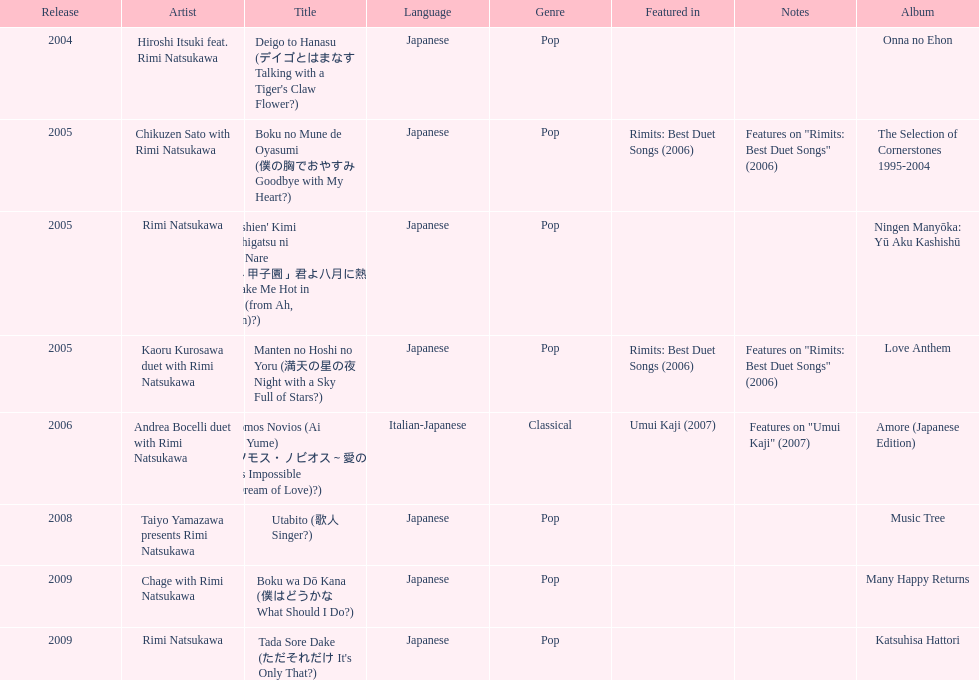I'm looking to parse the entire table for insights. Could you assist me with that? {'header': ['Release', 'Artist', 'Title', 'Language', 'Genre', 'Featured in', 'Notes', 'Album'], 'rows': [['2004', 'Hiroshi Itsuki feat. Rimi Natsukawa', "Deigo to Hanasu (デイゴとはまなす Talking with a Tiger's Claw Flower?)", 'Japanese', 'Pop', '', '', 'Onna no Ehon'], ['2005', 'Chikuzen Sato with Rimi Natsukawa', 'Boku no Mune de Oyasumi (僕の胸でおやすみ Goodbye with My Heart?)', 'Japanese', 'Pop', 'Rimits: Best Duet Songs (2006)', 'Features on "Rimits: Best Duet Songs" (2006)', 'The Selection of Cornerstones 1995-2004'], ['2005', 'Rimi Natsukawa', "'Aa Kōshien' Kimi yo Hachigatsu ni Atsuku Nare (「あゝ甲子園」君よ八月に熱くなれ You Make Me Hot in August (from Ah, Kōshien)?)", 'Japanese', 'Pop', '', '', 'Ningen Manyōka: Yū Aku Kashishū'], ['2005', 'Kaoru Kurosawa duet with Rimi Natsukawa', 'Manten no Hoshi no Yoru (満天の星の夜 Night with a Sky Full of Stars?)', 'Japanese', 'Pop', 'Rimits: Best Duet Songs (2006)', 'Features on "Rimits: Best Duet Songs" (2006)', 'Love Anthem'], ['2006', 'Andrea Bocelli duet with Rimi Natsukawa', "Somos Novios (Ai no Yume) (ソモス・ノビオス～愛の夢 It's Impossible (Dream of Love)?)", 'Italian-Japanese', 'Classical', 'Umui Kaji (2007)', 'Features on "Umui Kaji" (2007)', 'Amore (Japanese Edition)'], ['2008', 'Taiyo Yamazawa presents Rimi Natsukawa', 'Utabito (歌人 Singer?)', 'Japanese', 'Pop', '', '', 'Music Tree'], ['2009', 'Chage with Rimi Natsukawa', 'Boku wa Dō Kana (僕はどうかな What Should I Do?)', 'Japanese', 'Pop', '', '', 'Many Happy Returns'], ['2009', 'Rimi Natsukawa', "Tada Sore Dake (ただそれだけ It's Only That?)", 'Japanese', 'Pop', '', '', 'Katsuhisa Hattori']]} How many titles have only one artist? 2. 